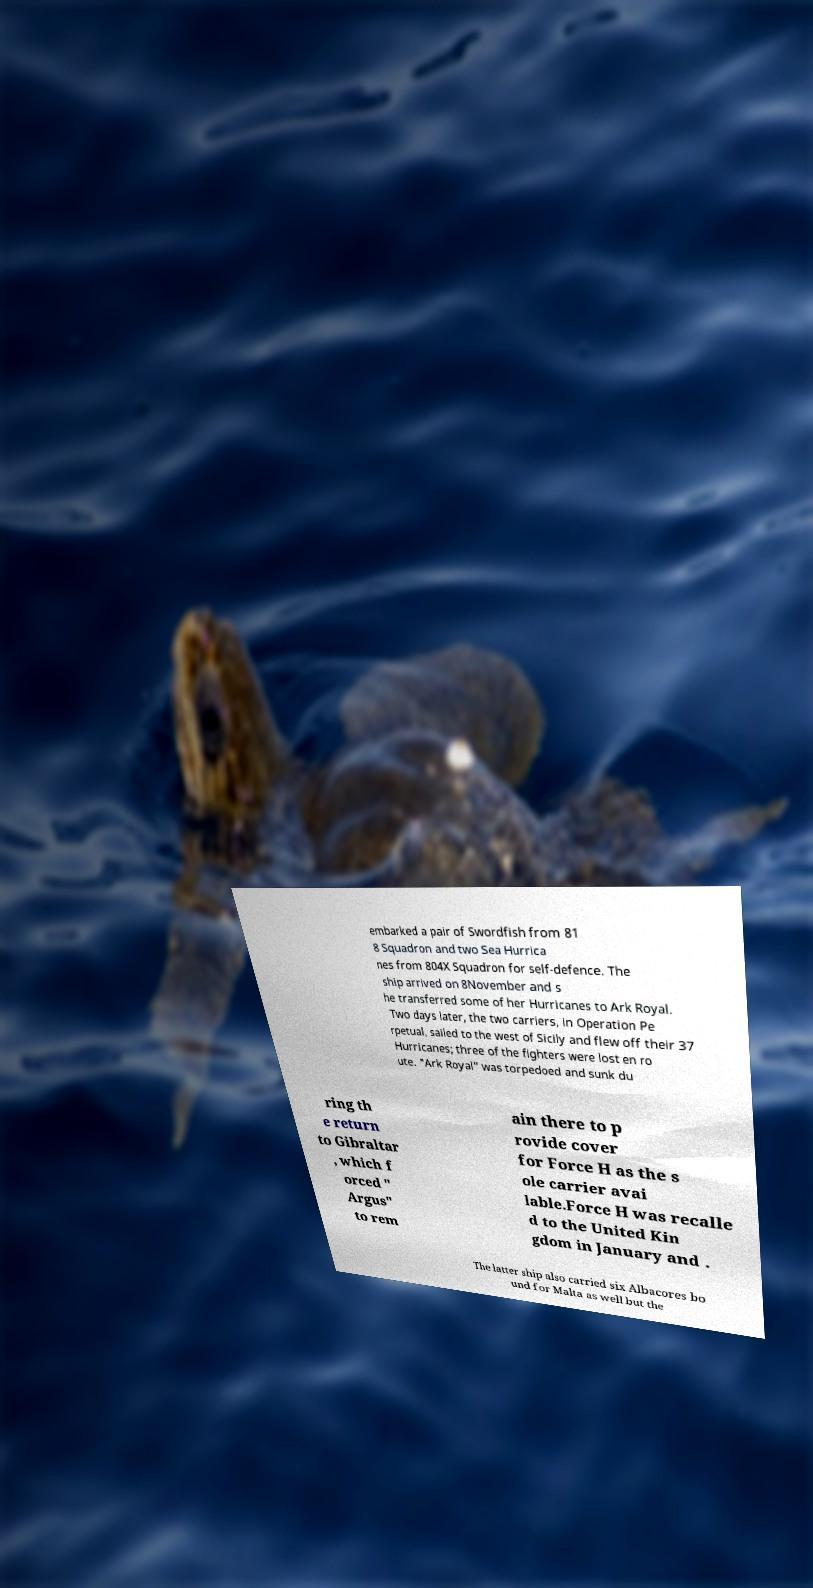I need the written content from this picture converted into text. Can you do that? embarked a pair of Swordfish from 81 8 Squadron and two Sea Hurrica nes from 804X Squadron for self-defence. The ship arrived on 8November and s he transferred some of her Hurricanes to Ark Royal. Two days later, the two carriers, in Operation Pe rpetual, sailed to the west of Sicily and flew off their 37 Hurricanes; three of the fighters were lost en ro ute. "Ark Royal" was torpedoed and sunk du ring th e return to Gibraltar , which f orced " Argus" to rem ain there to p rovide cover for Force H as the s ole carrier avai lable.Force H was recalle d to the United Kin gdom in January and . The latter ship also carried six Albacores bo und for Malta as well but the 